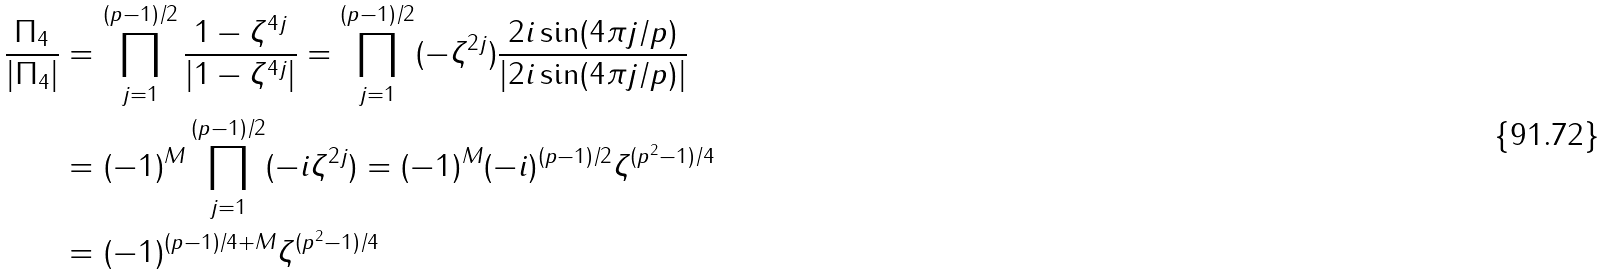<formula> <loc_0><loc_0><loc_500><loc_500>\frac { \Pi _ { 4 } } { | \Pi _ { 4 } | } & = \prod _ { j = 1 } ^ { ( p - 1 ) / 2 } \frac { 1 - \zeta ^ { 4 j } } { | 1 - \zeta ^ { 4 j } | } = \prod _ { j = 1 } ^ { ( p - 1 ) / 2 } ( - \zeta ^ { 2 j } ) \frac { 2 i \sin ( 4 \pi j / p ) } { | 2 i \sin ( 4 \pi j / p ) | } \\ & = ( - 1 ) ^ { M } \prod _ { j = 1 } ^ { ( p - 1 ) / 2 } ( - i \zeta ^ { 2 j } ) = ( - 1 ) ^ { M } ( - i ) ^ { ( p - 1 ) / 2 } \zeta ^ { ( p ^ { 2 } - 1 ) / 4 } \\ & = ( - 1 ) ^ { ( p - 1 ) / 4 + M } \zeta ^ { ( p ^ { 2 } - 1 ) / 4 }</formula> 